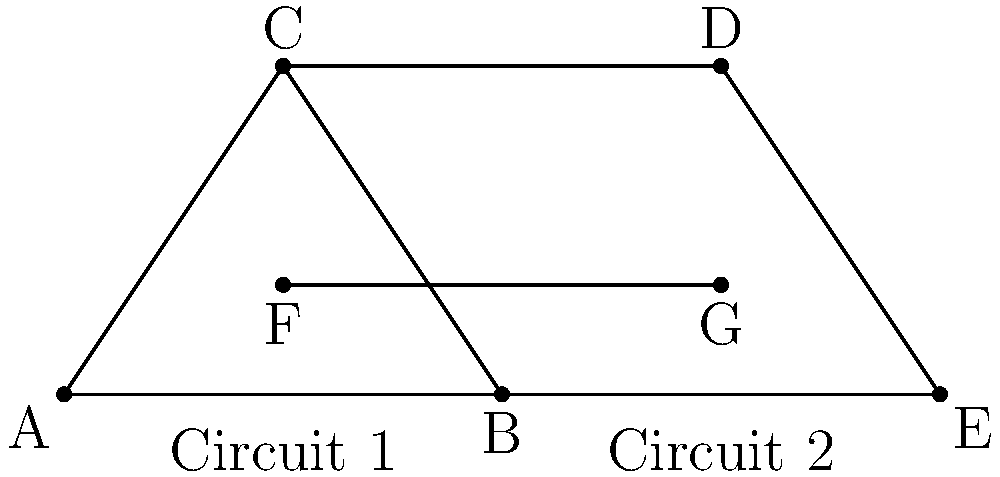In the complex circuit diagram above, which two triangles are congruent? Provide your answer using the vertex labels. To identify congruent triangles in this circuit diagram, we need to analyze the properties of the triangles present:

1. First, let's identify the triangles: ABC, CDE, and BCE.

2. To determine congruence, we need to check if any pair of these triangles satisfy one of the congruence criteria: SSS (Side-Side-Side), SAS (Side-Angle-Side), or ASA (Angle-Side-Angle).

3. Observe that line FG is parallel to BE and intersects AC and CD at their midpoints.

4. This means that AF = FC and DG = GC.

5. Since F and G are midpoints of AC and CD respectively, we can conclude that AC = CD.

6. Triangle ABC shares the side AC with triangle CDE.

7. The line FG creates congruent angles:
   - Angle BAC ≅ Angle DCE (alternate interior angles)
   - Angle BCA ≅ Angle CED (alternate interior angles)

8. With one side (AC = CD) and two angles (BAC ≅ DCE and BCA ≅ CED) being congruent, we can conclude that triangles ABC and CDE are congruent by the ASA (Angle-Side-Angle) criterion.

Therefore, the congruent triangles in this circuit diagram are ABC and CDE.
Answer: ABC and CDE 